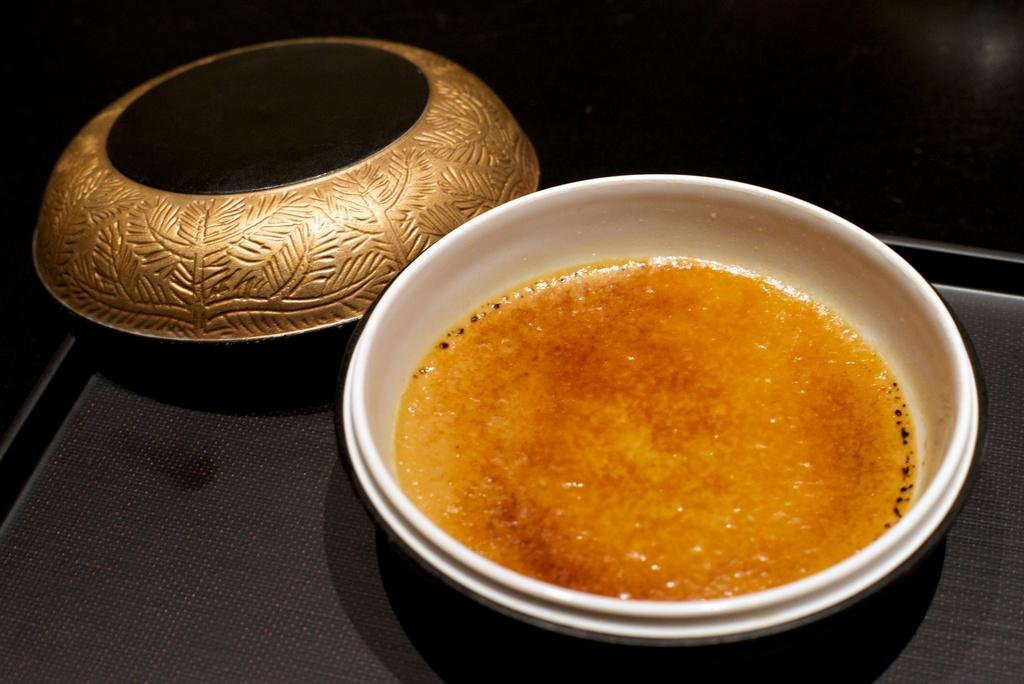What is placed on the tray in the image? There is a bowl on a tray in the image. Is there anything else on the tray besides the bowl? Yes, there is a lid on the tray. What is inside the bowl? The bowl contains a food item. What can be observed about the image's background? The background of the image is dark. What type of bun is being used as a bridge to cross the powder in the image? There is no bun, bridge, or powder present in the image. 